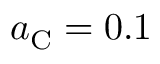Convert formula to latex. <formula><loc_0><loc_0><loc_500><loc_500>a _ { C } = 0 . 1</formula> 